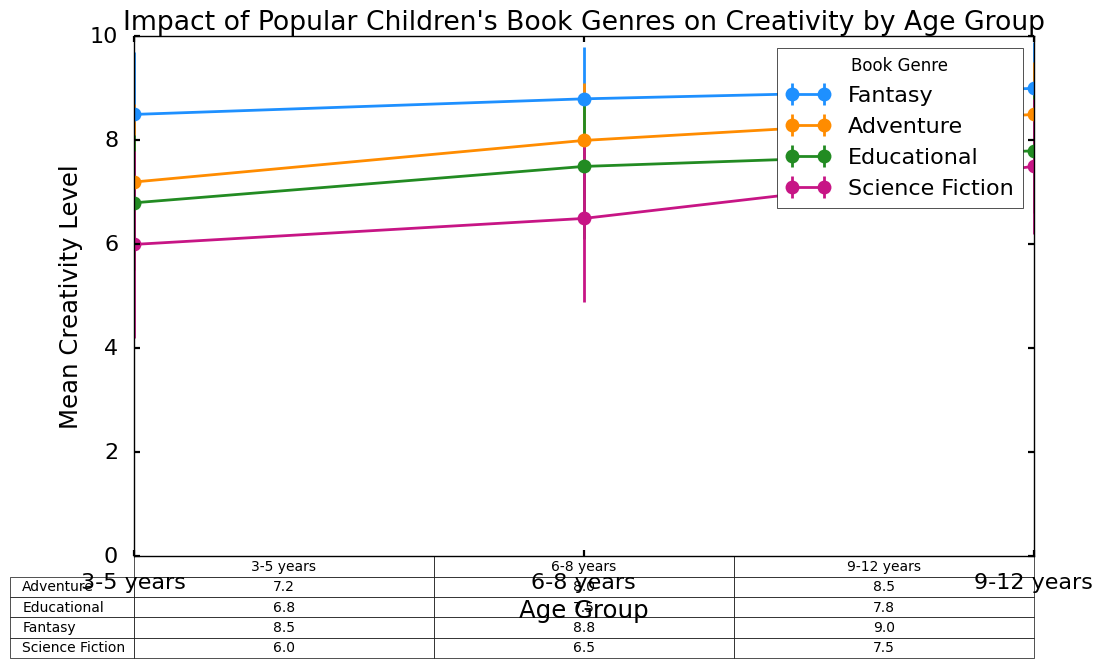What genre shows the highest mean creativity level for children aged 3-5 years? By checking the table, we see that "Fantasy" for ages 3-5 has the highest mean creativity level of 8.5.
Answer: Fantasy How does the mean creativity level for "Educational" books in children aged 9-12 years compare to those aged 6-8 years? From the table, the mean creativity level for "Educational" books for ages 9-12 years is 7.8, while for ages 6-8 years, it's 7.5, indicating that it's slightly higher for the older group.
Answer: 7.8 is higher than 7.5 What age group has the lowest standard deviation in creativity levels for "Adventure" books? Checking the standard deviations in the table, children aged 9-12 years have the lowest standard deviation for "Adventure" books, which is 1.0.
Answer: 9-12 years What's the average mean creativity level across all genres for children aged 6-8 years? Sum the mean creativity levels for ages 6-8 years (8.8 + 8.0 + 7.5 + 6.5) and divide by 4. The total is 30.8, so the average is 30.8 / 4 = 7.7.
Answer: 7.7 Which genre shows the greatest increase in mean creativity level from the 3-5 years group to the 9-12 years group? Calculate the increase for each genre from 3-5 to 9-12: Fantasy (9.0 - 8.5 = 0.5), Adventure (8.5 - 7.2 = 1.3), Educational (7.8 - 6.8 = 1.0), Science Fiction (7.5 - 6.0 = 1.5). "Science Fiction" shows the greatest increase of 1.5.
Answer: Science Fiction Which book genre has the most consistent creativity levels across all age groups, based on standard deviations? The most consistent genre will have the lowest standard deviations across all age groups. "Fantasy" has standard deviations of 1.2, 1.0, and 0.9, which are the lowest overall.
Answer: Fantasy What is the sum of the mean creativity levels of all genres for children aged 3-5 years? Add up the values for all genres for 3-5 years: 8.5 + 7.2 + 6.8 + 6.0 = 28.5.
Answer: 28.5 Which genre has the lowest mean creativity level for children aged 6-8 years, and what is that value? The table shows "Science Fiction" has the lowest mean creativity for ages 6-8 years at 6.5.
Answer: Science Fiction, 6.5 How much does the mean creativity level in "Fantasy" books change from 3-5 years to 6-8 years and then to 9-12 years? Calculate the change incrementally: from 3-5 to 6-8: (8.8 - 8.5 = 0.3), then from 6-8 to 9-12: (9.0 - 8.8 = 0.2). The total change is 0.3 + 0.2 = 0.5.
Answer: 0.5 What is the difference in mean creativity level between "Fantasy" and "Science Fiction" books for 9-12 years old? Subtract the mean for "Science Fiction" (7.5) from the mean for "Fantasy" (9.0): 9.0 - 7.5 = 1.5.
Answer: 1.5 